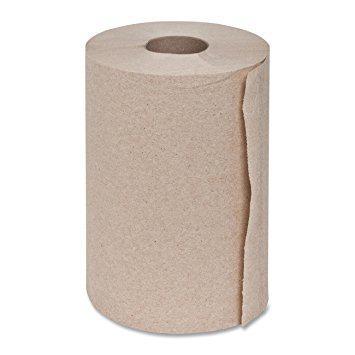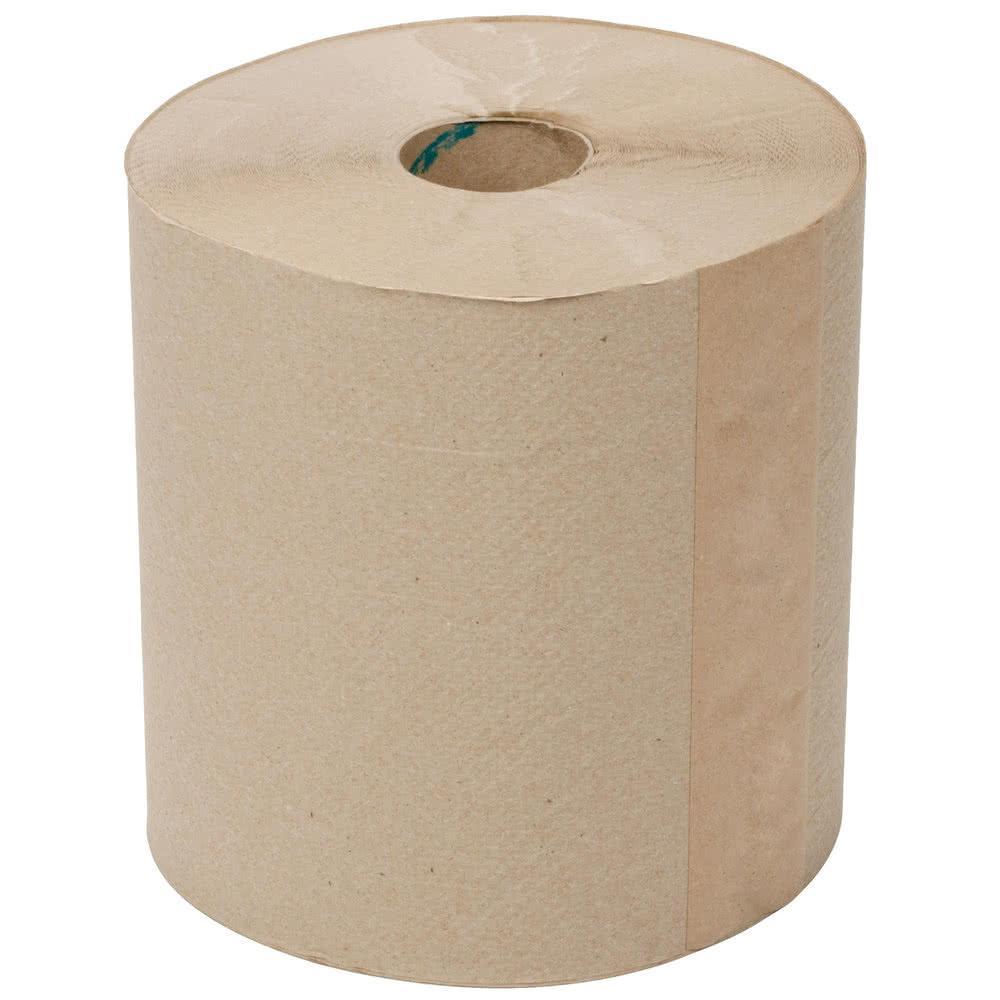The first image is the image on the left, the second image is the image on the right. For the images shown, is this caption "No paper towel rolls have sheets unfurled." true? Answer yes or no. Yes. The first image is the image on the left, the second image is the image on the right. For the images displayed, is the sentence "The roll of paper in the image on the left is partially unrolled" factually correct? Answer yes or no. No. 